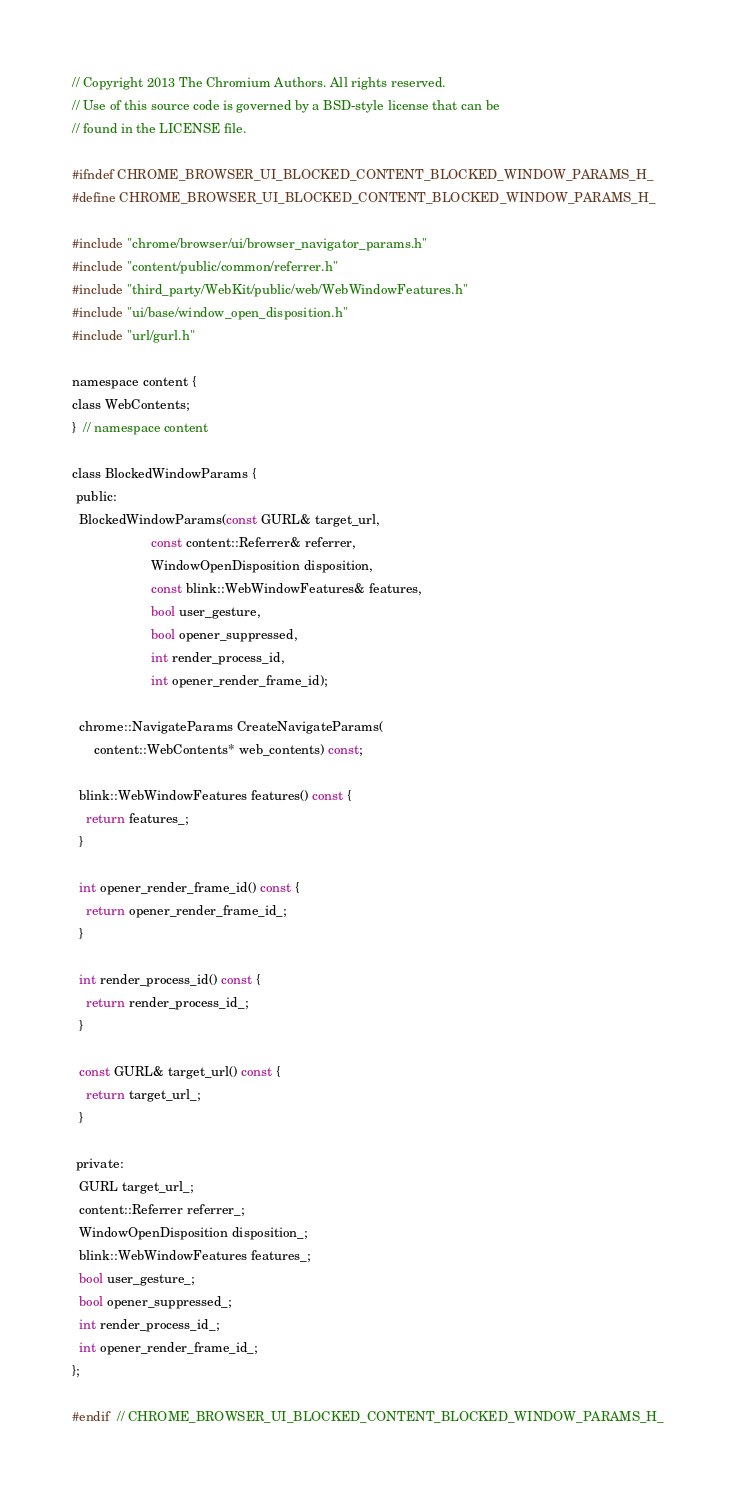<code> <loc_0><loc_0><loc_500><loc_500><_C_>// Copyright 2013 The Chromium Authors. All rights reserved.
// Use of this source code is governed by a BSD-style license that can be
// found in the LICENSE file.

#ifndef CHROME_BROWSER_UI_BLOCKED_CONTENT_BLOCKED_WINDOW_PARAMS_H_
#define CHROME_BROWSER_UI_BLOCKED_CONTENT_BLOCKED_WINDOW_PARAMS_H_

#include "chrome/browser/ui/browser_navigator_params.h"
#include "content/public/common/referrer.h"
#include "third_party/WebKit/public/web/WebWindowFeatures.h"
#include "ui/base/window_open_disposition.h"
#include "url/gurl.h"

namespace content {
class WebContents;
}  // namespace content

class BlockedWindowParams {
 public:
  BlockedWindowParams(const GURL& target_url,
                      const content::Referrer& referrer,
                      WindowOpenDisposition disposition,
                      const blink::WebWindowFeatures& features,
                      bool user_gesture,
                      bool opener_suppressed,
                      int render_process_id,
                      int opener_render_frame_id);

  chrome::NavigateParams CreateNavigateParams(
      content::WebContents* web_contents) const;

  blink::WebWindowFeatures features() const {
    return features_;
  }

  int opener_render_frame_id() const {
    return opener_render_frame_id_;
  }

  int render_process_id() const {
    return render_process_id_;
  }

  const GURL& target_url() const {
    return target_url_;
  }

 private:
  GURL target_url_;
  content::Referrer referrer_;
  WindowOpenDisposition disposition_;
  blink::WebWindowFeatures features_;
  bool user_gesture_;
  bool opener_suppressed_;
  int render_process_id_;
  int opener_render_frame_id_;
};

#endif  // CHROME_BROWSER_UI_BLOCKED_CONTENT_BLOCKED_WINDOW_PARAMS_H_
</code> 